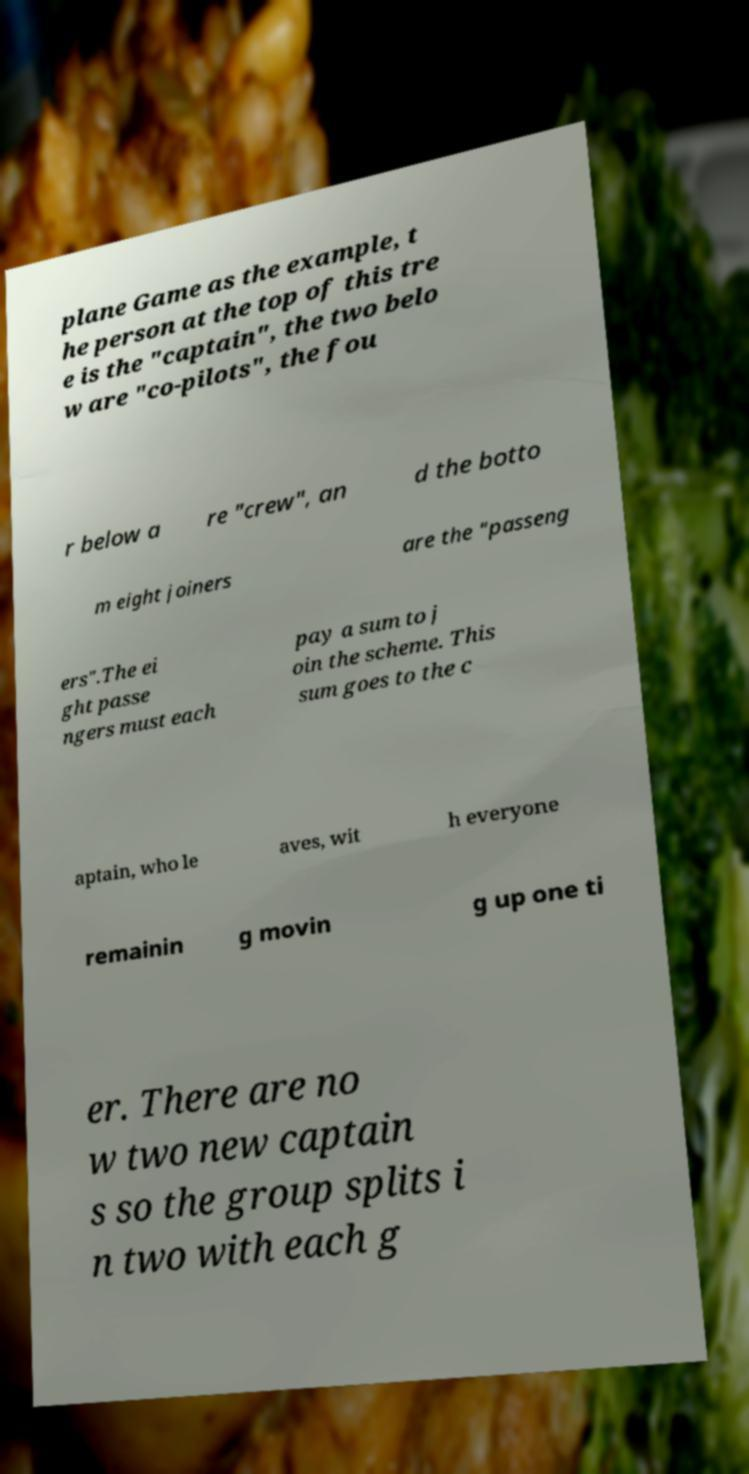Please read and relay the text visible in this image. What does it say? plane Game as the example, t he person at the top of this tre e is the "captain", the two belo w are "co-pilots", the fou r below a re "crew", an d the botto m eight joiners are the "passeng ers".The ei ght passe ngers must each pay a sum to j oin the scheme. This sum goes to the c aptain, who le aves, wit h everyone remainin g movin g up one ti er. There are no w two new captain s so the group splits i n two with each g 